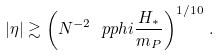Convert formula to latex. <formula><loc_0><loc_0><loc_500><loc_500>| \eta | \gtrsim \left ( N ^ { - 2 } \ p p h i \frac { H _ { * } } { m _ { P } } \right ) ^ { 1 / 1 0 } \, .</formula> 